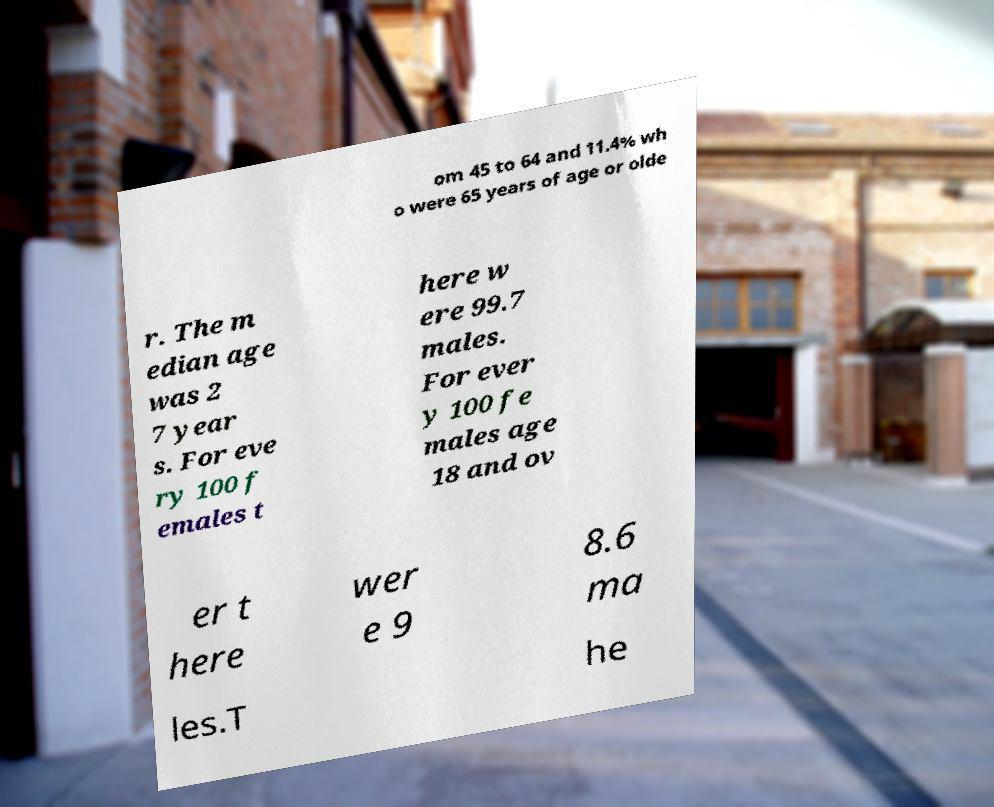Please read and relay the text visible in this image. What does it say? om 45 to 64 and 11.4% wh o were 65 years of age or olde r. The m edian age was 2 7 year s. For eve ry 100 f emales t here w ere 99.7 males. For ever y 100 fe males age 18 and ov er t here wer e 9 8.6 ma les.T he 